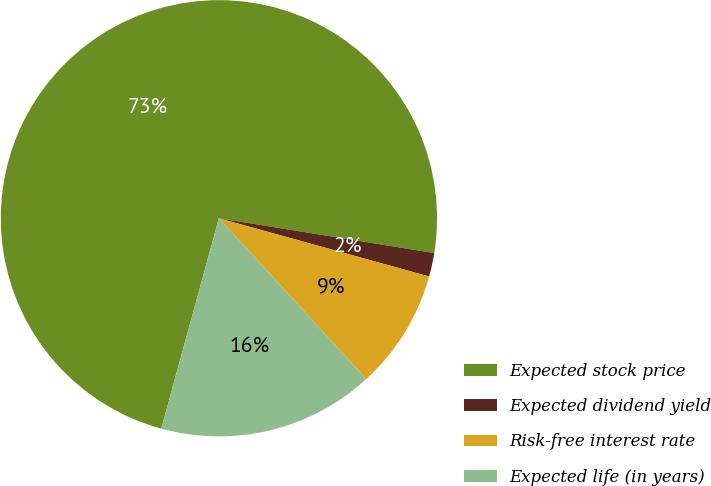<chart> <loc_0><loc_0><loc_500><loc_500><pie_chart><fcel>Expected stock price<fcel>Expected dividend yield<fcel>Risk-free interest rate<fcel>Expected life (in years)<nl><fcel>73.3%<fcel>1.75%<fcel>8.9%<fcel>16.06%<nl></chart> 